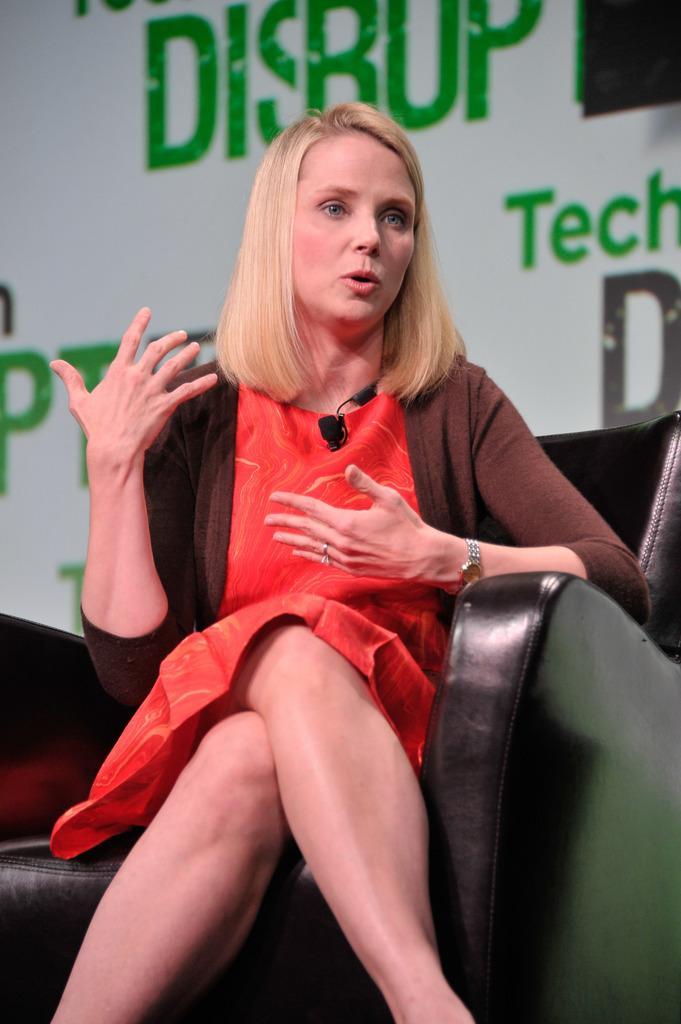In one or two sentences, can you explain what this image depicts? In this image we can see a person on a couch. Behind the person we can see a wall with text. 